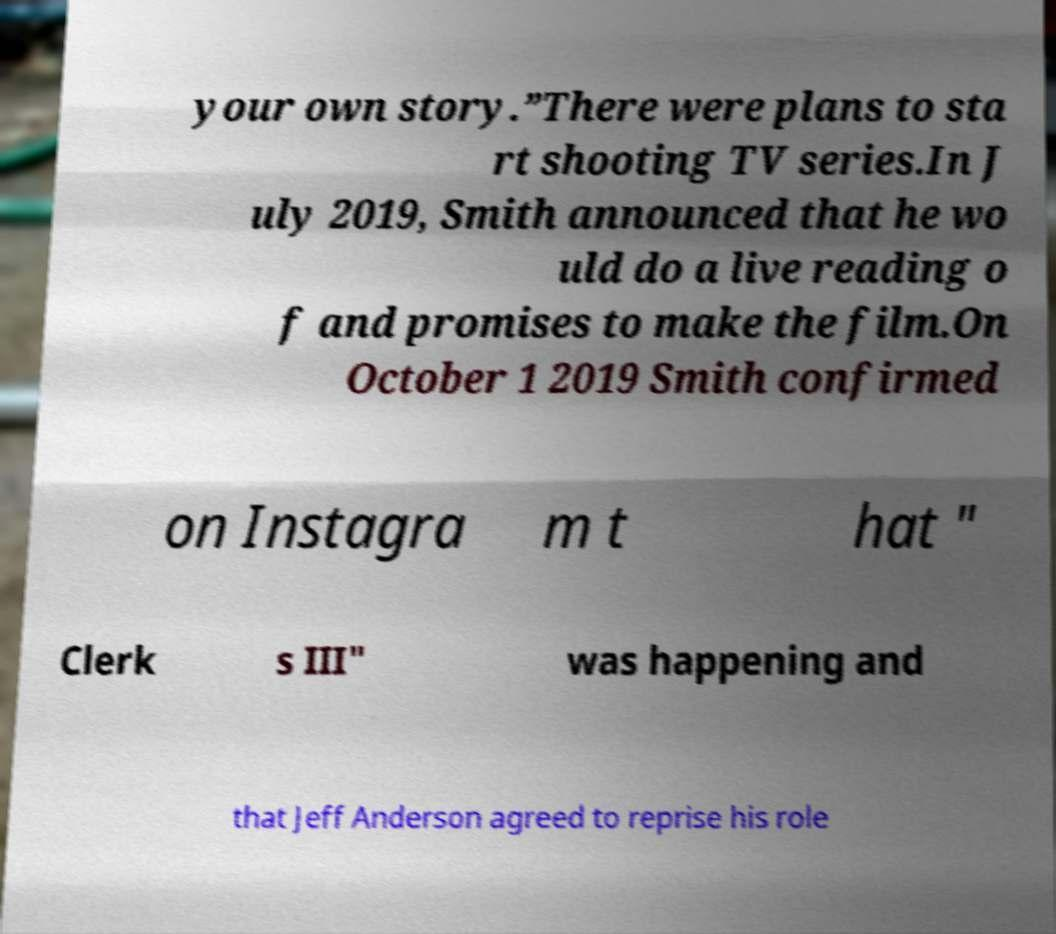Could you assist in decoding the text presented in this image and type it out clearly? your own story.”There were plans to sta rt shooting TV series.In J uly 2019, Smith announced that he wo uld do a live reading o f and promises to make the film.On October 1 2019 Smith confirmed on Instagra m t hat " Clerk s III" was happening and that Jeff Anderson agreed to reprise his role 